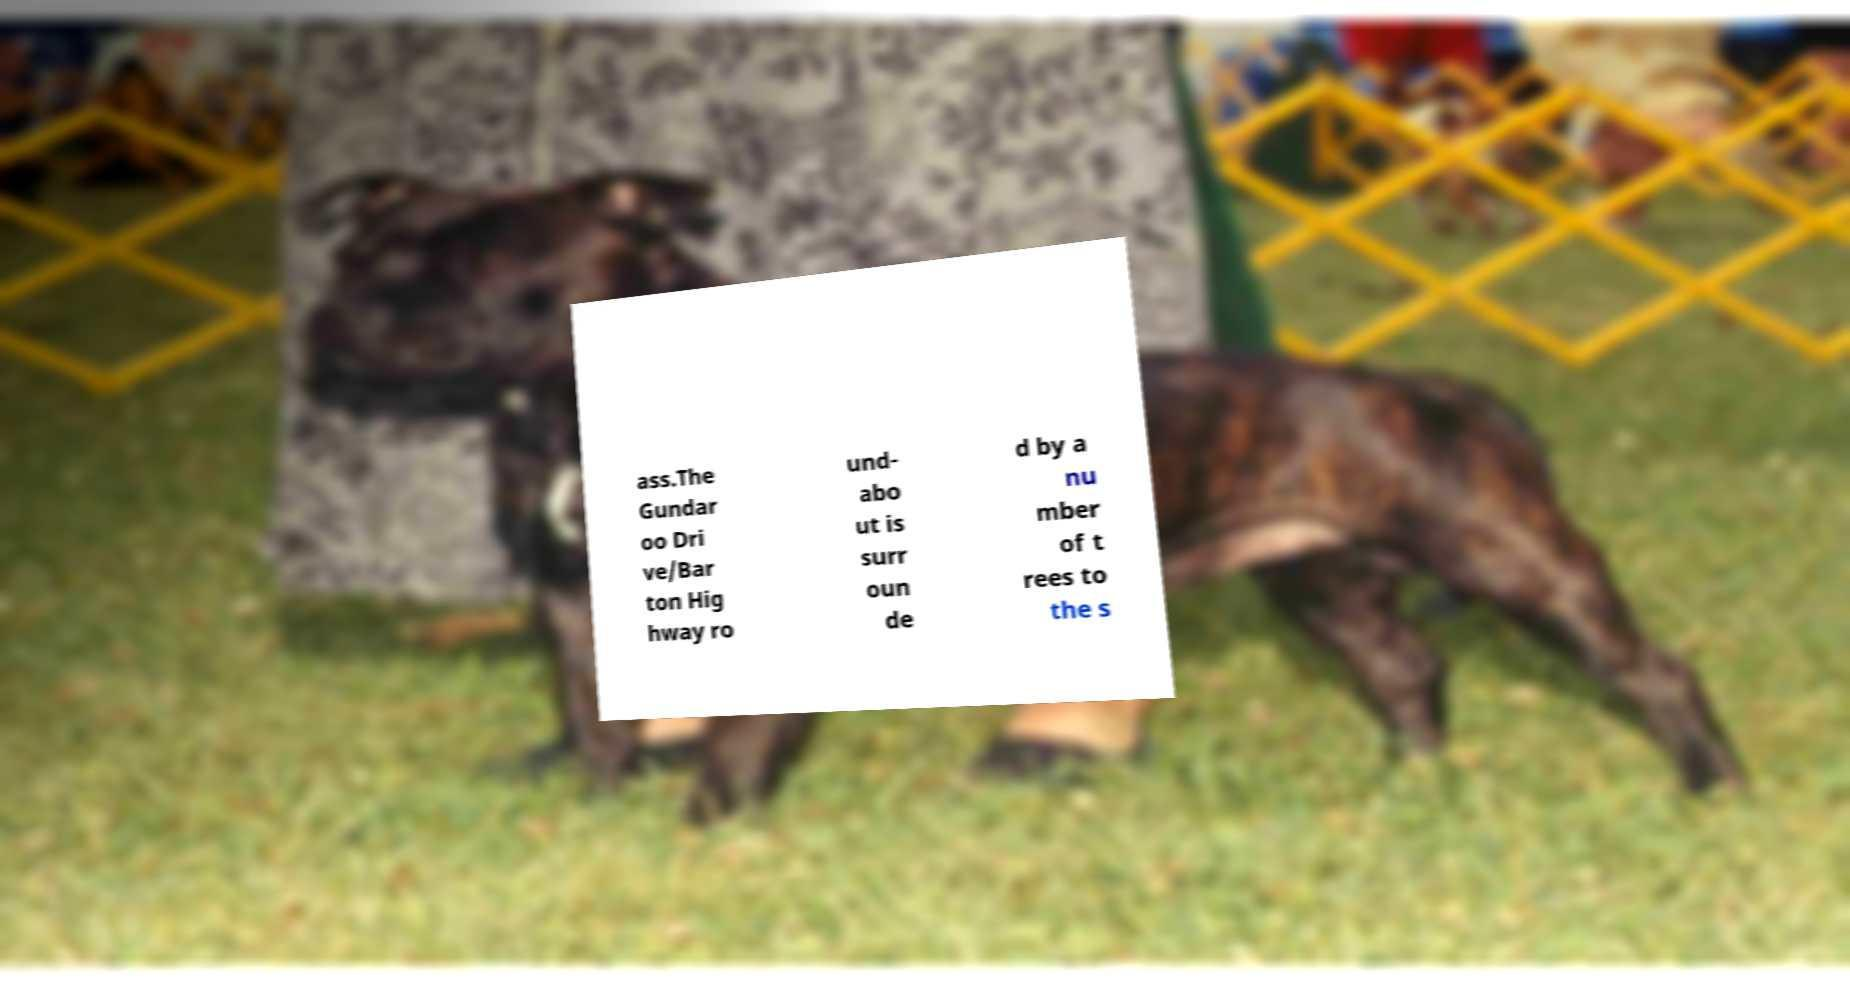Please identify and transcribe the text found in this image. ass.The Gundar oo Dri ve/Bar ton Hig hway ro und- abo ut is surr oun de d by a nu mber of t rees to the s 